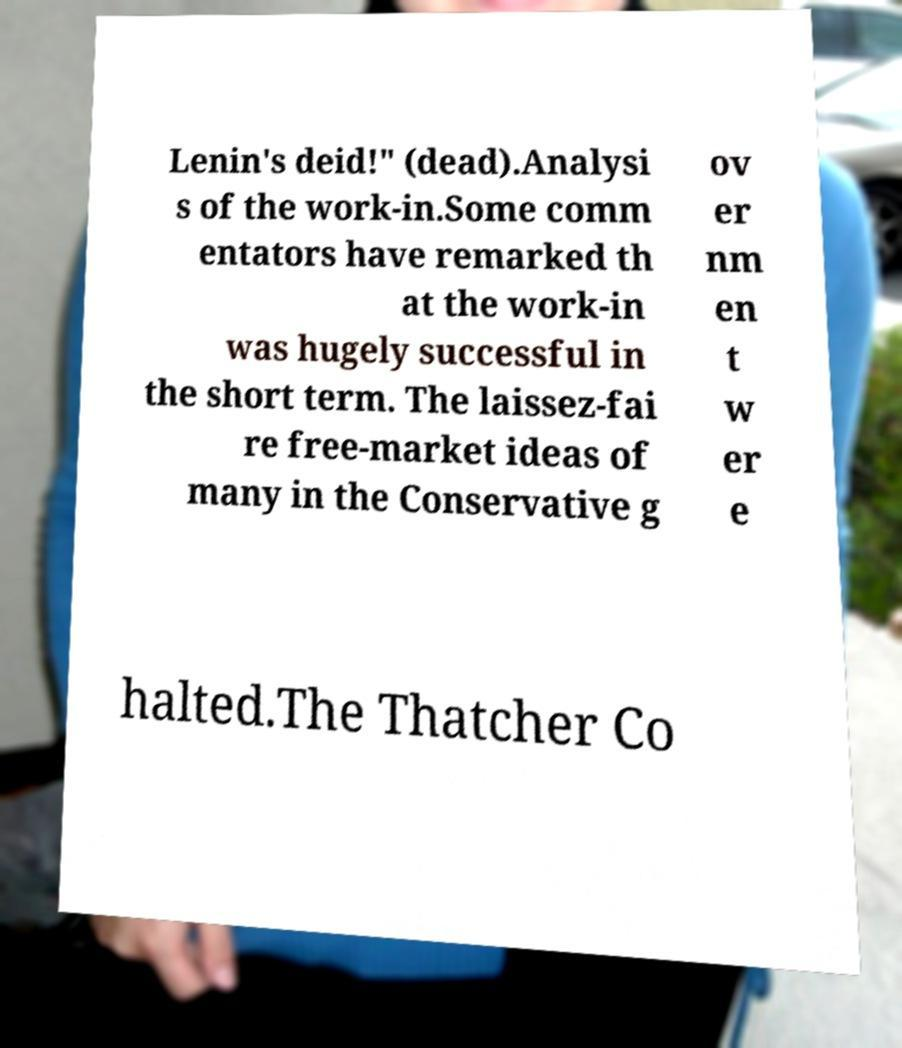Can you accurately transcribe the text from the provided image for me? Lenin's deid!" (dead).Analysi s of the work-in.Some comm entators have remarked th at the work-in was hugely successful in the short term. The laissez-fai re free-market ideas of many in the Conservative g ov er nm en t w er e halted.The Thatcher Co 